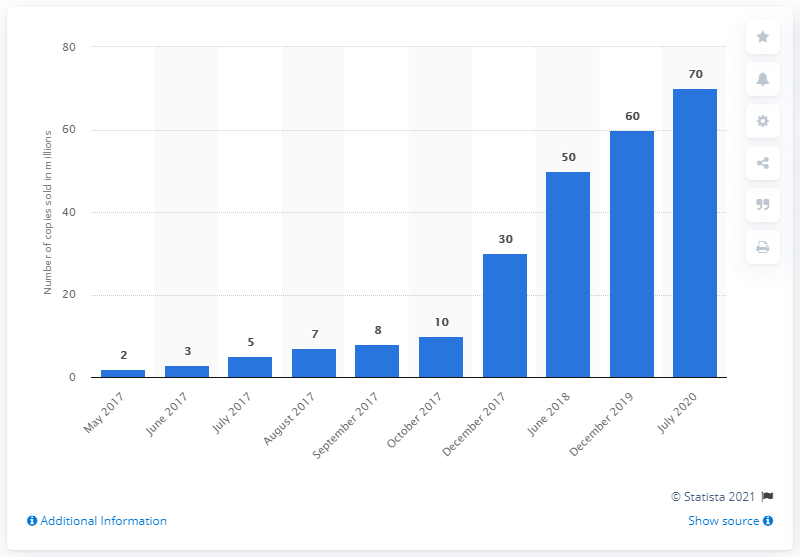List a handful of essential elements in this visual. PlayerUnknown's Battlegrounds reached 70 million players in July 2020. The full release of PlayerUnknown's Battlegrounds occurred in December 2017. In July 2020, an estimated 70 million people played PlayerUnknown's Battlegrounds. 